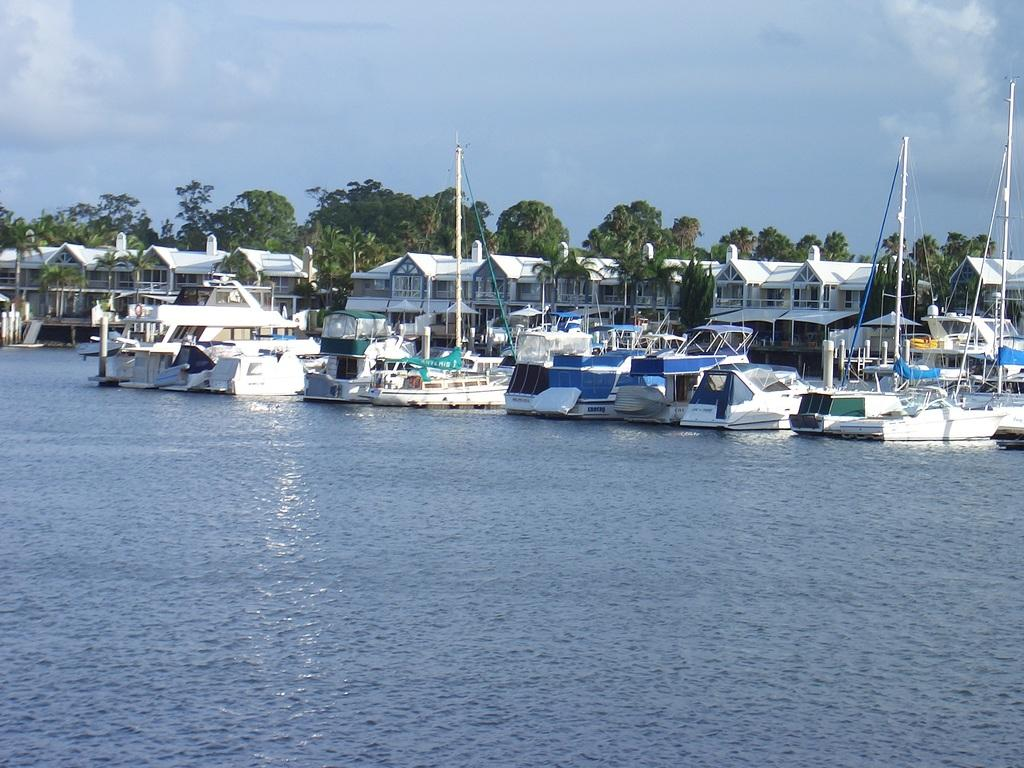What type of view is shown in the image? The image is an outside view. What can be seen at the bottom of the image? There is water visible at the bottom of the image. What is located in the middle of the image? There are many boats, buildings, trees, and poles in the middle of the image. What is visible at the top of the image? The sky is visible at the top of the image. What flavor of cream can be seen growing on the trees in the image? There is no cream growing on the trees in the image; the trees are not associated with any cream. What type of mint is used to decorate the poles in the image? There is no mint present in the image, nor are the poles decorated with any mint. 